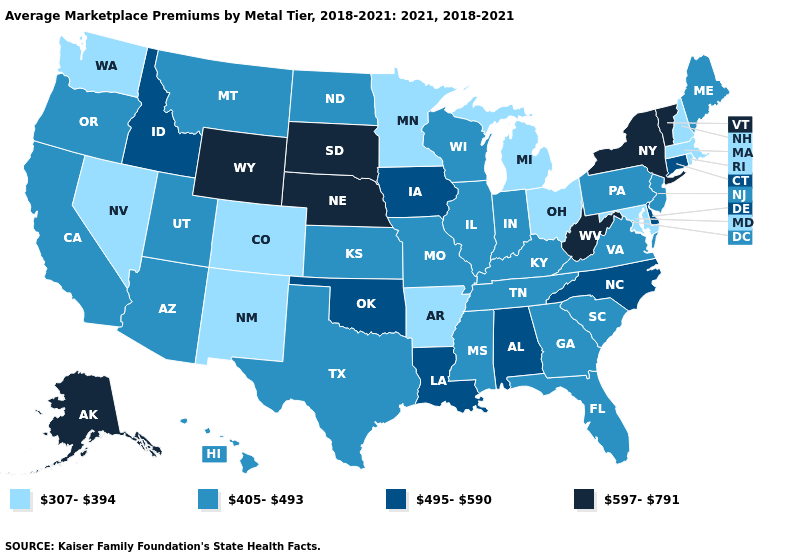Does Maryland have a lower value than Oregon?
Give a very brief answer. Yes. What is the lowest value in the USA?
Be succinct. 307-394. How many symbols are there in the legend?
Give a very brief answer. 4. Is the legend a continuous bar?
Give a very brief answer. No. Name the states that have a value in the range 597-791?
Quick response, please. Alaska, Nebraska, New York, South Dakota, Vermont, West Virginia, Wyoming. What is the value of Louisiana?
Concise answer only. 495-590. Name the states that have a value in the range 597-791?
Keep it brief. Alaska, Nebraska, New York, South Dakota, Vermont, West Virginia, Wyoming. Among the states that border Nevada , which have the highest value?
Write a very short answer. Idaho. What is the highest value in the West ?
Write a very short answer. 597-791. What is the lowest value in the USA?
Give a very brief answer. 307-394. How many symbols are there in the legend?
Keep it brief. 4. What is the value of Arkansas?
Write a very short answer. 307-394. Name the states that have a value in the range 597-791?
Write a very short answer. Alaska, Nebraska, New York, South Dakota, Vermont, West Virginia, Wyoming. What is the value of Iowa?
Keep it brief. 495-590. Does North Dakota have the highest value in the USA?
Short answer required. No. 